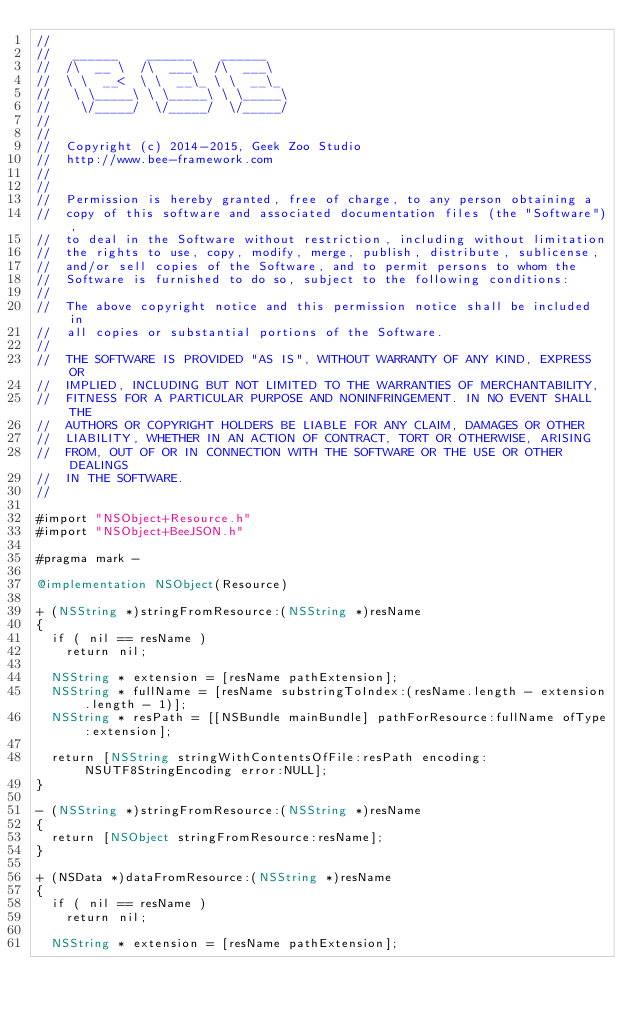Convert code to text. <code><loc_0><loc_0><loc_500><loc_500><_ObjectiveC_>//
//	 ______    ______    ______
//	/\  __ \  /\  ___\  /\  ___\
//	\ \  __<  \ \  __\_ \ \  __\_
//	 \ \_____\ \ \_____\ \ \_____\
//	  \/_____/  \/_____/  \/_____/
//
//
//	Copyright (c) 2014-2015, Geek Zoo Studio
//	http://www.bee-framework.com
//
//
//	Permission is hereby granted, free of charge, to any person obtaining a
//	copy of this software and associated documentation files (the "Software"),
//	to deal in the Software without restriction, including without limitation
//	the rights to use, copy, modify, merge, publish, distribute, sublicense,
//	and/or sell copies of the Software, and to permit persons to whom the
//	Software is furnished to do so, subject to the following conditions:
//
//	The above copyright notice and this permission notice shall be included in
//	all copies or substantial portions of the Software.
//
//	THE SOFTWARE IS PROVIDED "AS IS", WITHOUT WARRANTY OF ANY KIND, EXPRESS OR
//	IMPLIED, INCLUDING BUT NOT LIMITED TO THE WARRANTIES OF MERCHANTABILITY,
//	FITNESS FOR A PARTICULAR PURPOSE AND NONINFRINGEMENT. IN NO EVENT SHALL THE
//	AUTHORS OR COPYRIGHT HOLDERS BE LIABLE FOR ANY CLAIM, DAMAGES OR OTHER
//	LIABILITY, WHETHER IN AN ACTION OF CONTRACT, TORT OR OTHERWISE, ARISING
//	FROM, OUT OF OR IN CONNECTION WITH THE SOFTWARE OR THE USE OR OTHER DEALINGS
//	IN THE SOFTWARE.
//

#import "NSObject+Resource.h"
#import "NSObject+BeeJSON.h"

#pragma mark -

@implementation NSObject(Resource)

+ (NSString *)stringFromResource:(NSString *)resName
{
	if ( nil == resName )
		return nil;

	NSString * extension = [resName pathExtension];
	NSString * fullName = [resName substringToIndex:(resName.length - extension.length - 1)];
	NSString * resPath = [[NSBundle mainBundle] pathForResource:fullName ofType:extension];
	
	return [NSString stringWithContentsOfFile:resPath encoding:NSUTF8StringEncoding error:NULL];
}

- (NSString *)stringFromResource:(NSString *)resName
{
	return [NSObject stringFromResource:resName];
}

+ (NSData *)dataFromResource:(NSString *)resName
{
	if ( nil == resName )
		return nil;
	
	NSString * extension = [resName pathExtension];</code> 